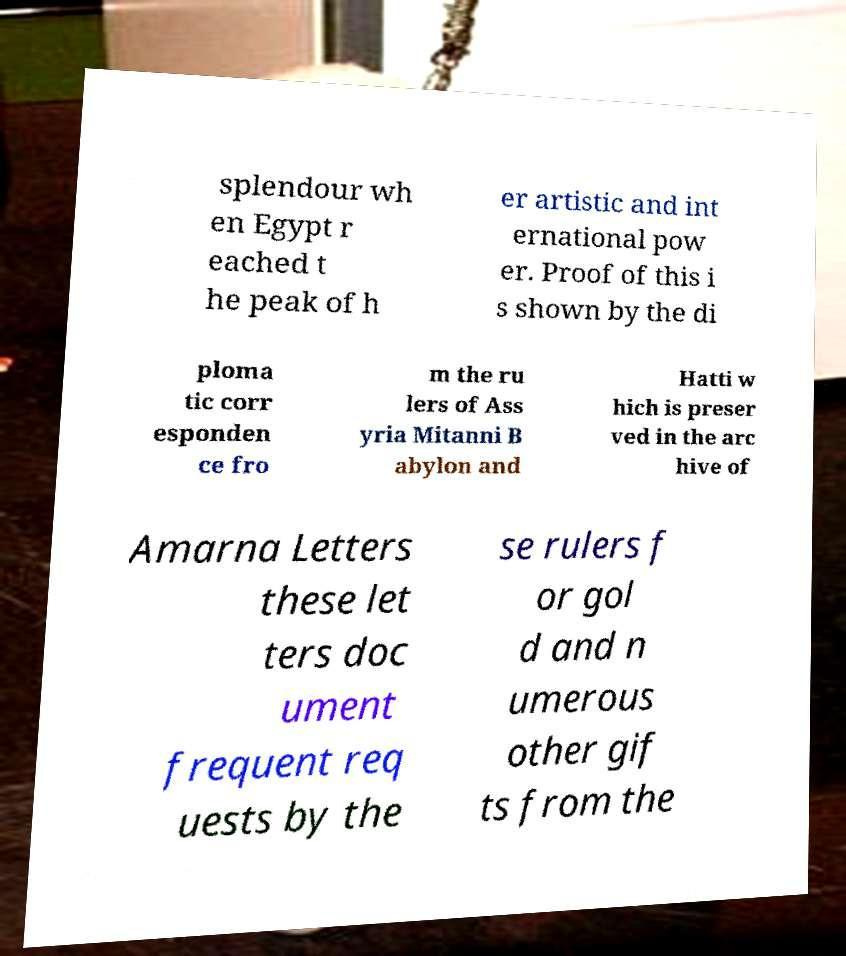Could you assist in decoding the text presented in this image and type it out clearly? splendour wh en Egypt r eached t he peak of h er artistic and int ernational pow er. Proof of this i s shown by the di ploma tic corr esponden ce fro m the ru lers of Ass yria Mitanni B abylon and Hatti w hich is preser ved in the arc hive of Amarna Letters these let ters doc ument frequent req uests by the se rulers f or gol d and n umerous other gif ts from the 